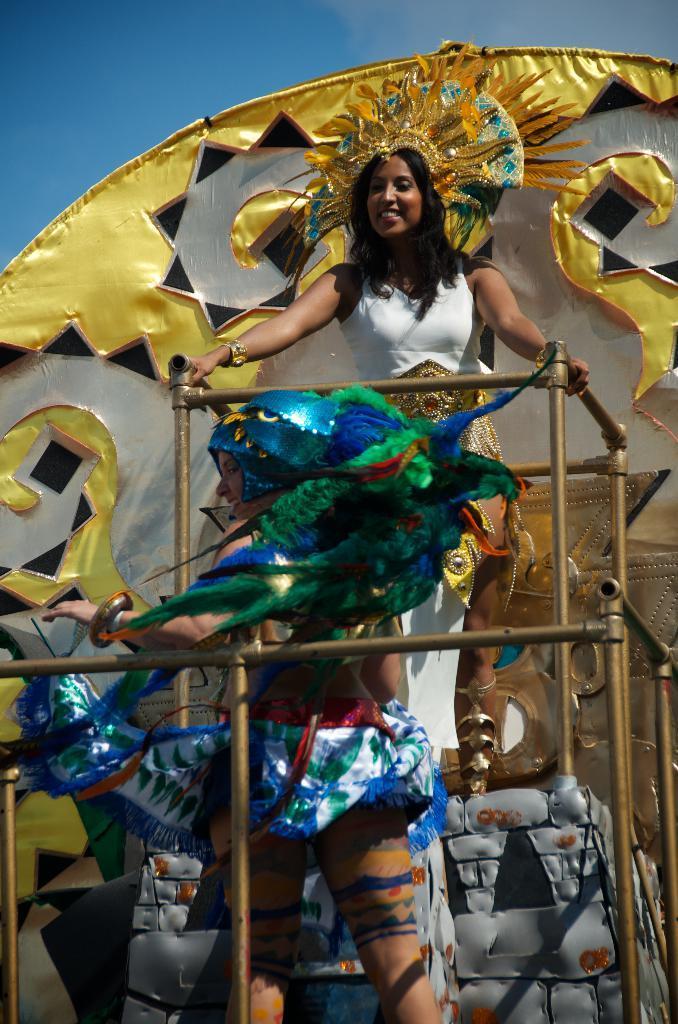In one or two sentences, can you explain what this image depicts? In the middle of this image, there is a woman in a white color t-shirt, smiling, standing on a platform and holding an object which is made up with pipes. In front of her, there is another woman smiling and standing. In the background, there is a decorative cloth and there is blue sky. 